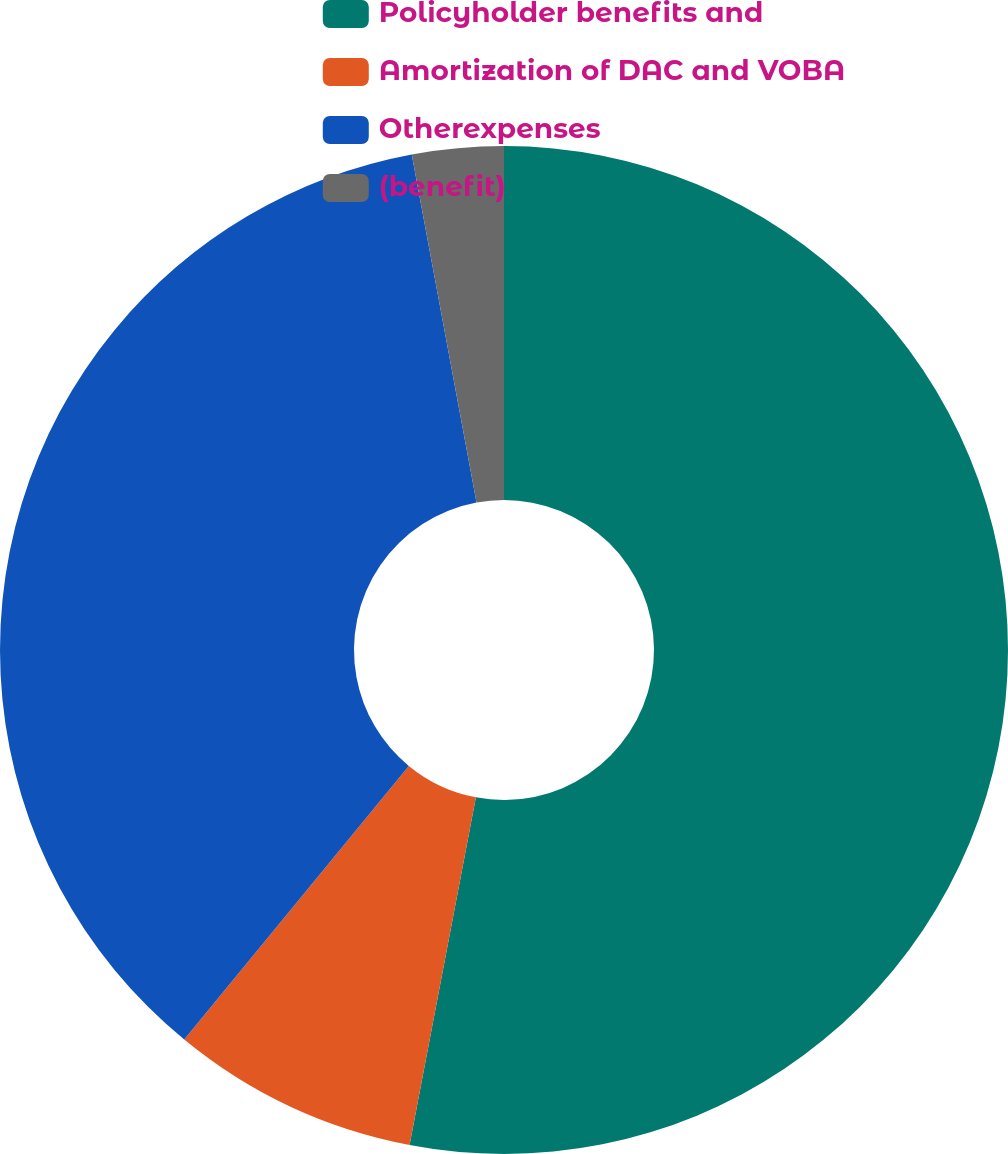<chart> <loc_0><loc_0><loc_500><loc_500><pie_chart><fcel>Policyholder benefits and<fcel>Amortization of DAC and VOBA<fcel>Otherexpenses<fcel>(benefit)<nl><fcel>53.0%<fcel>7.94%<fcel>36.13%<fcel>2.93%<nl></chart> 